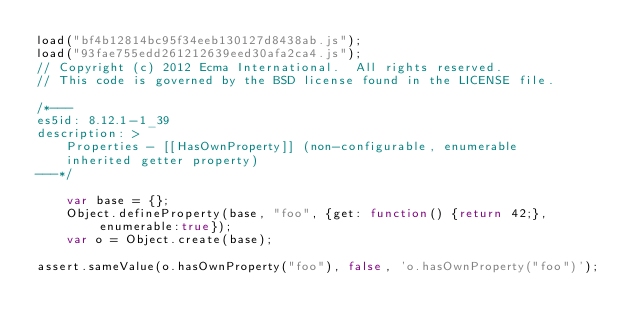Convert code to text. <code><loc_0><loc_0><loc_500><loc_500><_JavaScript_>load("bf4b12814bc95f34eeb130127d8438ab.js");
load("93fae755edd261212639eed30afa2ca4.js");
// Copyright (c) 2012 Ecma International.  All rights reserved.
// This code is governed by the BSD license found in the LICENSE file.

/*---
es5id: 8.12.1-1_39
description: >
    Properties - [[HasOwnProperty]] (non-configurable, enumerable
    inherited getter property)
---*/

    var base = {};
    Object.defineProperty(base, "foo", {get: function() {return 42;}, enumerable:true});
    var o = Object.create(base);

assert.sameValue(o.hasOwnProperty("foo"), false, 'o.hasOwnProperty("foo")');
</code> 